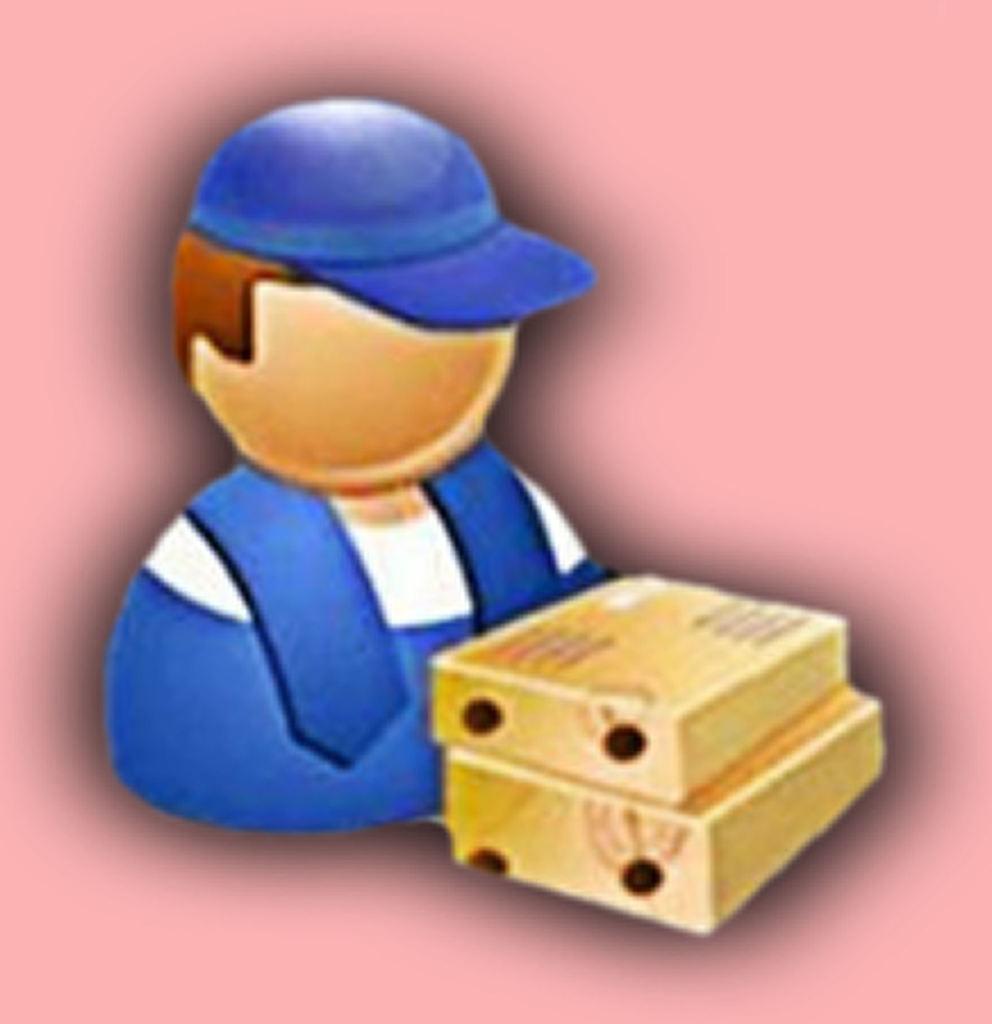Describe this image in one or two sentences. In this picture we can see depiction of a person and two boxes, we can see a cap here. 